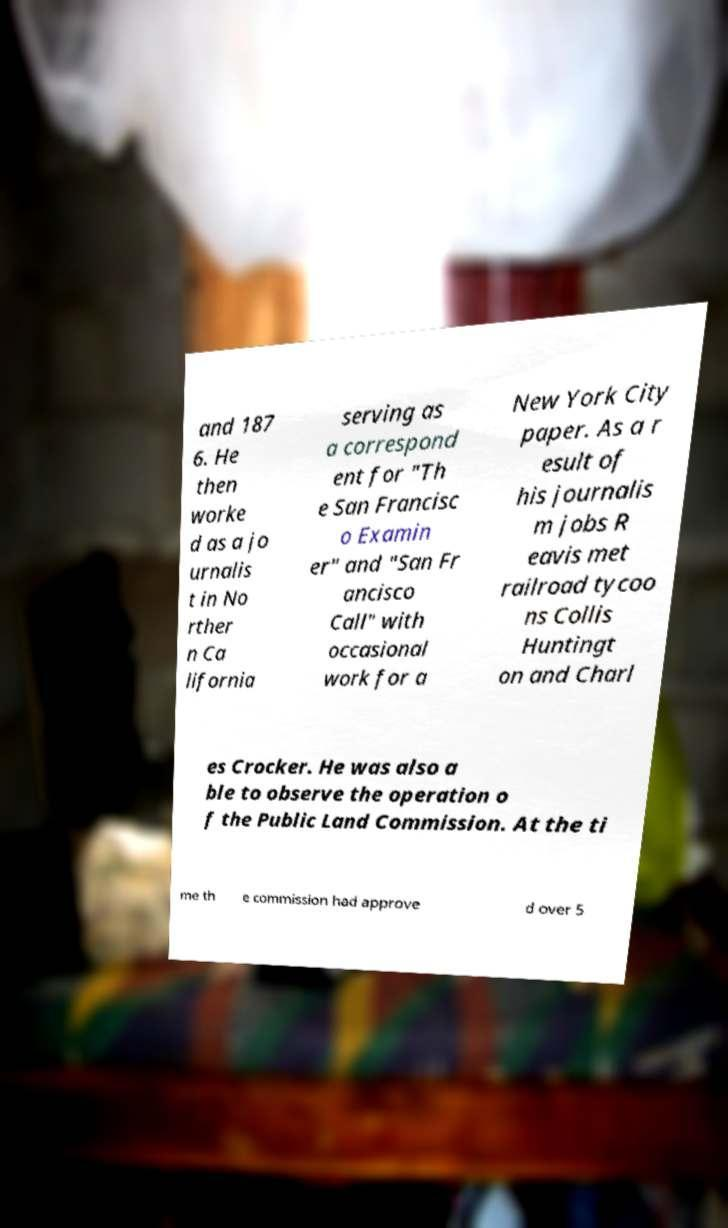Can you accurately transcribe the text from the provided image for me? and 187 6. He then worke d as a jo urnalis t in No rther n Ca lifornia serving as a correspond ent for "Th e San Francisc o Examin er" and "San Fr ancisco Call" with occasional work for a New York City paper. As a r esult of his journalis m jobs R eavis met railroad tycoo ns Collis Huntingt on and Charl es Crocker. He was also a ble to observe the operation o f the Public Land Commission. At the ti me th e commission had approve d over 5 